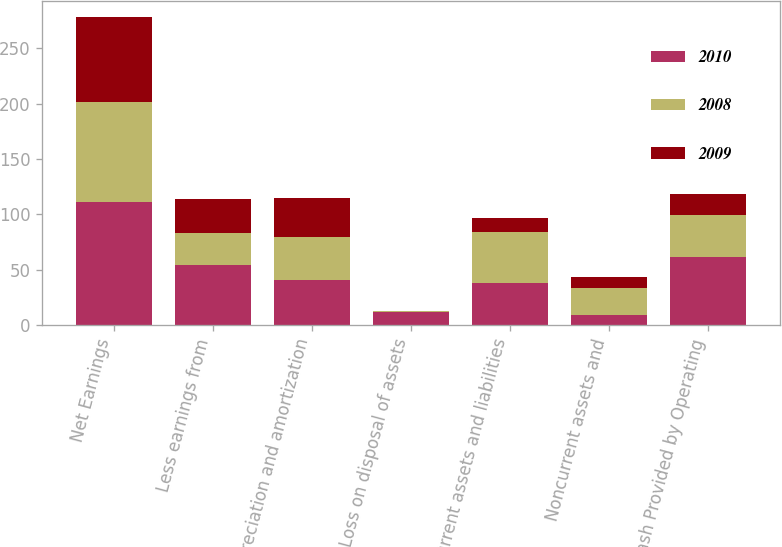<chart> <loc_0><loc_0><loc_500><loc_500><stacked_bar_chart><ecel><fcel>Net Earnings<fcel>Less earnings from<fcel>Depreciation and amortization<fcel>Loss on disposal of assets<fcel>Current assets and liabilities<fcel>Noncurrent assets and<fcel>Cash Provided by Operating<nl><fcel>2010<fcel>111.5<fcel>54.4<fcel>40.8<fcel>11.7<fcel>37.5<fcel>8.8<fcel>61.5<nl><fcel>2008<fcel>89.6<fcel>29.1<fcel>38.3<fcel>0.9<fcel>46.8<fcel>24.3<fcel>37.5<nl><fcel>2009<fcel>77.3<fcel>30.1<fcel>35.8<fcel>0.2<fcel>12<fcel>10.1<fcel>19.4<nl></chart> 